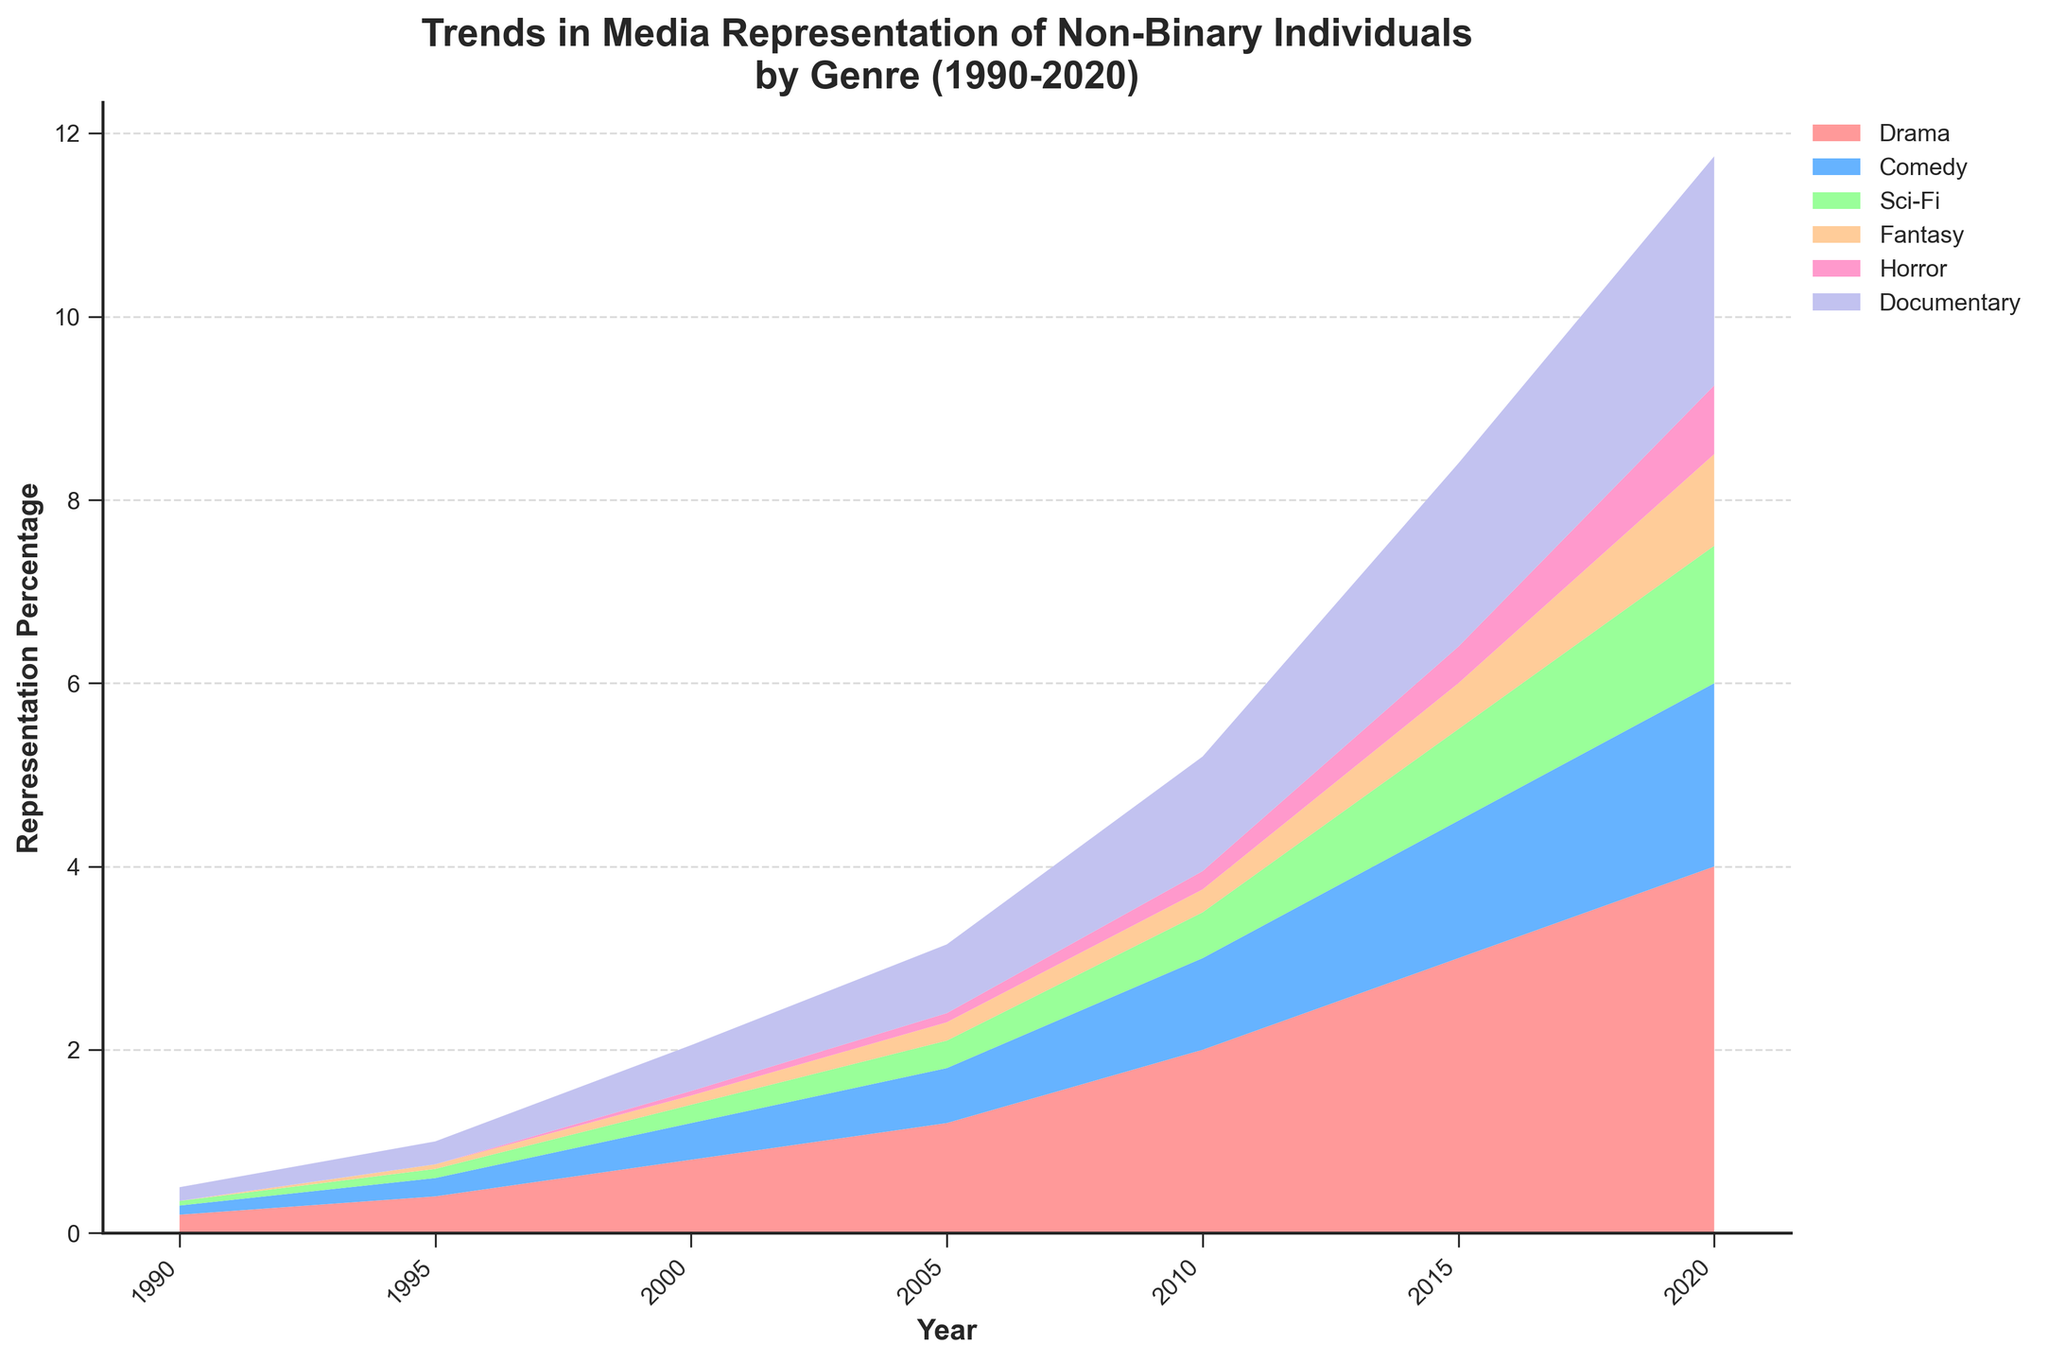what is the title of the plot? The title is at the top of the figure, summarizing the chart's main purpose. It reads "Trends in Media Representation of Non-Binary Individuals by Genre (1990-2020)".
Answer: Trends in Media Representation of Non-Binary Individuals by Genre (1990-2020) What genre had the highest representation percentage in 2020? By observing the 2020 section of the stream graph, the genre with the largest area is Drama, indicating the highest representation percentage.
Answer: Drama How many color segments are used in the plot? The plot uses six distinct colors representing six genres, indicated by different sections of the stream graph and the legend.
Answer: 6 Which genre showed the least representation in 1990? By examining the 1990 section of the stream graph, it's evident that Fantasy and Horror both show no representation, having a representation percentage of 0%.
Answer: Fantasy and Horror In which year did Comedy see a notable increase in representation percentage? Looking from left to right along the Comedy stream, a notable increase is observed around 2005, where the area of Comedy significantly expands.
Answer: 2005 What is the trend in representation percentage for the Sci-Fi genre between 1990 and 2020? Analyzing the Sci-Fi stream from 1990 to 2020, the representation percentage continuously increases, signified by the expanding area of the Sci-Fi section over the years.
Answer: Increasing Which genre had the highest representation percentage growth from 1990 to 2020? Comparing the area of each genre from 1990 to 2020, Drama shows the most substantial growth, having the largest increase in area over the years.
Answer: Drama What was the representation percentage for Documentaries in 2015? By looking at the 2015 segment of the Documentary stream, the representation percentage is observed to be 2.0%.
Answer: 2.0% Compare the representation percentages of Fantasy and Horror in 2010. Which had a higher percentage? In the 2010 section of the stream graph, the area for Fantasy is larger than that for Horror, indicating a higher representation percentage for Fantasy.
Answer: Fantasy What overall pattern can be observed about the representation of non-binary individuals across all genres from 1990 to 2020? Observing all streams over time, each genre's representation has gradually increased, signifying growing representation of non-binary individuals in media over the decades.
Answer: Increasing across all genres 